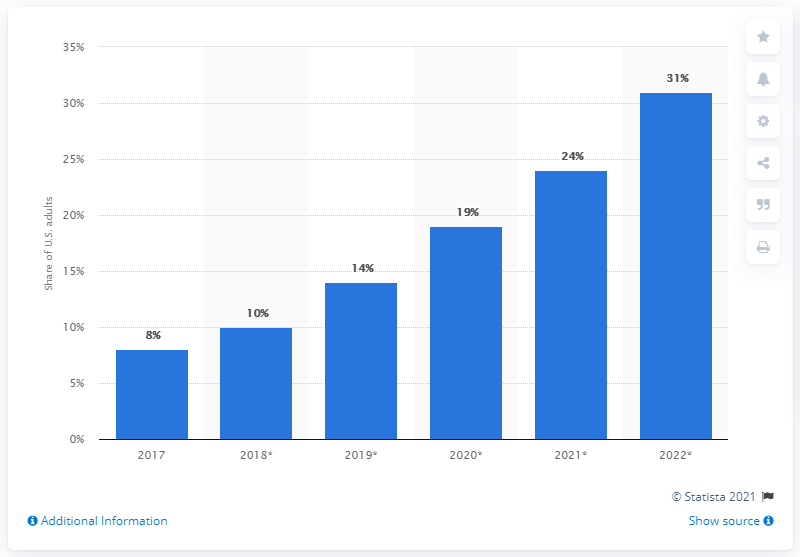Outline some significant characteristics in this image. The expected rise in the use of voice-enabled peer-to-peer payments in 2022 is projected to be significant. 